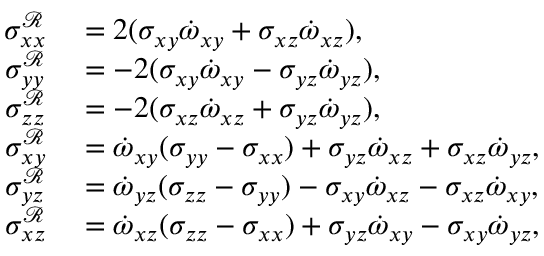Convert formula to latex. <formula><loc_0><loc_0><loc_500><loc_500>\begin{array} { r l } { \sigma _ { x x } ^ { \mathcal { R } } } & = 2 ( \sigma _ { x y } \dot { \omega } _ { x y } + \sigma _ { x z } \dot { \omega } _ { x z } ) , } \\ { \sigma _ { y y } ^ { \mathcal { R } } } & = - 2 ( \sigma _ { x y } \dot { \omega } _ { x y } - \sigma _ { y z } \dot { \omega } _ { y z } ) , } \\ { \sigma _ { z z } ^ { \mathcal { R } } } & = - 2 ( \sigma _ { x z } \dot { \omega } _ { x z } + \sigma _ { y z } \dot { \omega } _ { y z } ) , } \\ { \sigma _ { x y } ^ { \mathcal { R } } } & = \dot { \omega } _ { x y } ( \sigma _ { y y } - \sigma _ { x x } ) + \sigma _ { y z } \dot { \omega } _ { x z } + \sigma _ { x z } \dot { \omega } _ { y z } , } \\ { \sigma _ { y z } ^ { \mathcal { R } } } & = \dot { \omega } _ { y z } ( \sigma _ { z z } - \sigma _ { y y } ) - \sigma _ { x y } \dot { \omega } _ { x z } - \sigma _ { x z } \dot { \omega } _ { x y } , } \\ { \sigma _ { x z } ^ { \mathcal { R } } } & = \dot { \omega } _ { x z } ( \sigma _ { z z } - \sigma _ { x x } ) + \sigma _ { y z } \dot { \omega } _ { x y } - \sigma _ { x y } \dot { \omega } _ { y z } , } \end{array}</formula> 